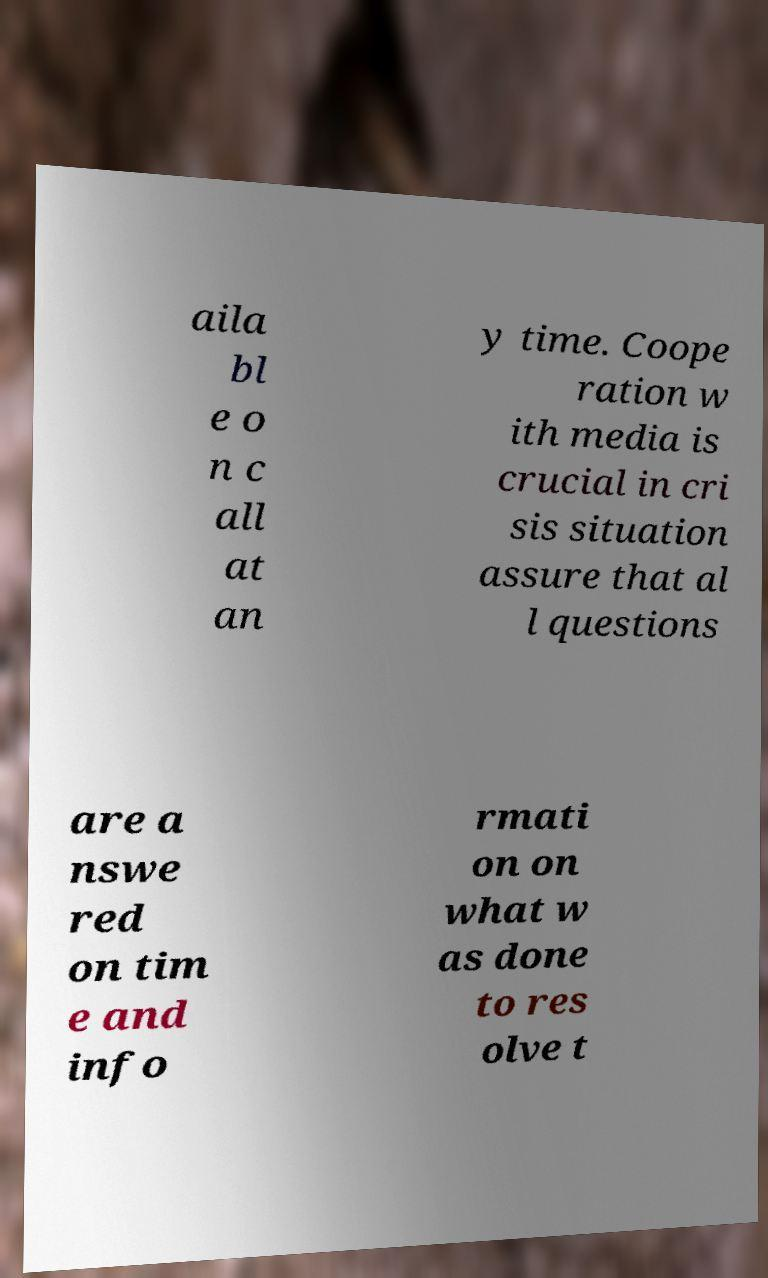What messages or text are displayed in this image? I need them in a readable, typed format. aila bl e o n c all at an y time. Coope ration w ith media is crucial in cri sis situation assure that al l questions are a nswe red on tim e and info rmati on on what w as done to res olve t 